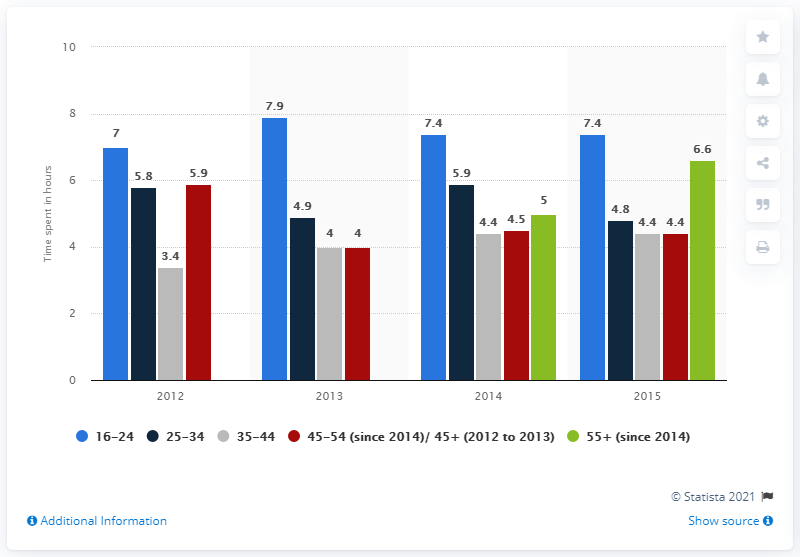Point out several critical features in this image. The graph depicts 4 years. The average hours worked over the 4 years was 4.05, calculated by adding up all the hours worked in that time frame and then dividing by the total number of years. 